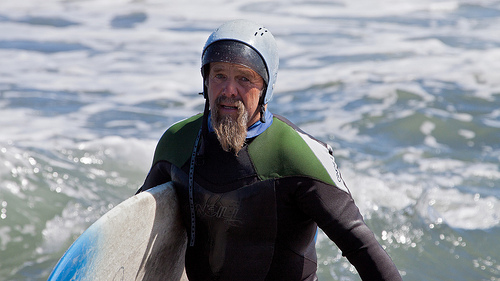What does the surfer's stance and expression tell us about his experience? The surfer's upright and relaxed stance, paired with a calm, focused expression, suggests that he is experienced and comfortable navigating the surf. 